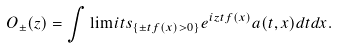Convert formula to latex. <formula><loc_0><loc_0><loc_500><loc_500>O _ { \pm } ( z ) = \int \lim i t s _ { \{ \pm t f ( x ) > 0 \} } e ^ { i z t f ( x ) } a ( t , x ) d t d x . \\</formula> 